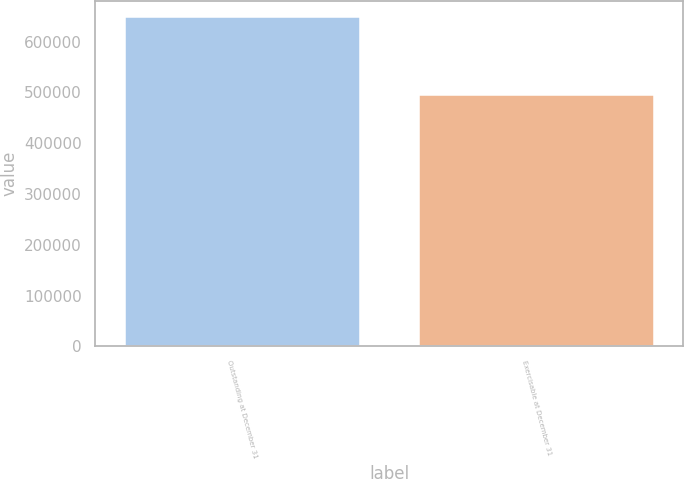<chart> <loc_0><loc_0><loc_500><loc_500><bar_chart><fcel>Outstanding at December 31<fcel>Exercisable at December 31<nl><fcel>648034<fcel>495334<nl></chart> 